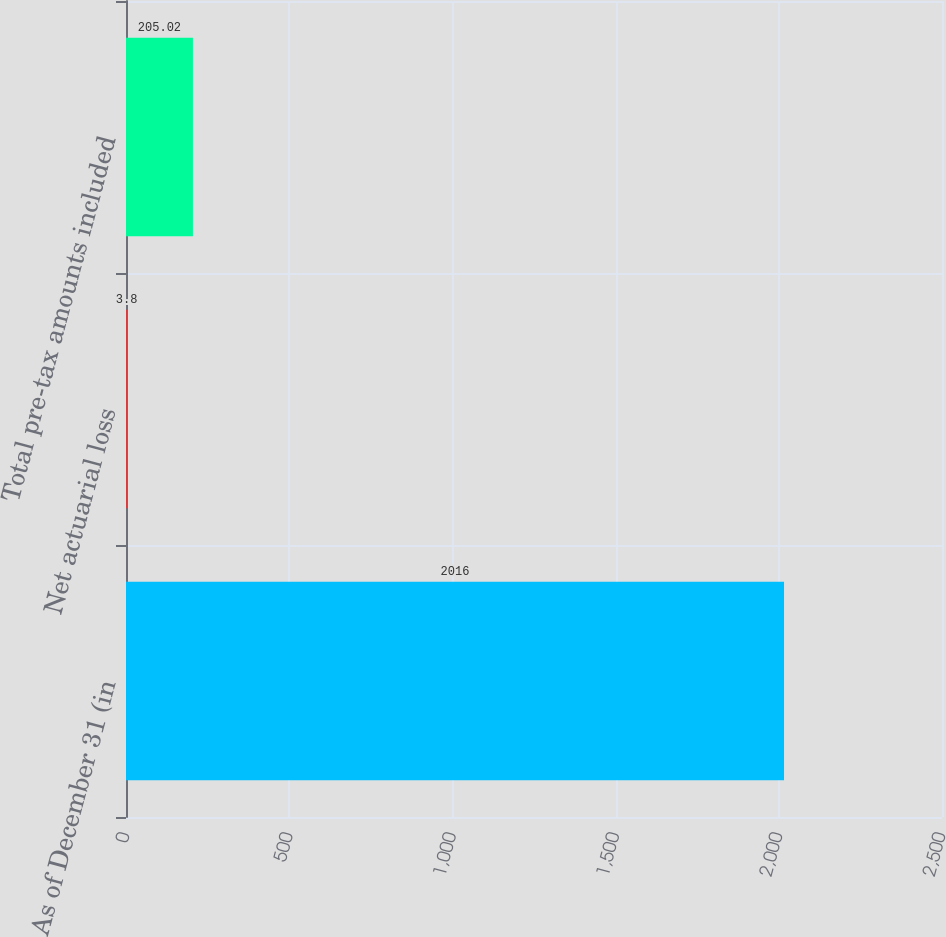Convert chart. <chart><loc_0><loc_0><loc_500><loc_500><bar_chart><fcel>As of December 31 (in<fcel>Net actuarial loss<fcel>Total pre-tax amounts included<nl><fcel>2016<fcel>3.8<fcel>205.02<nl></chart> 